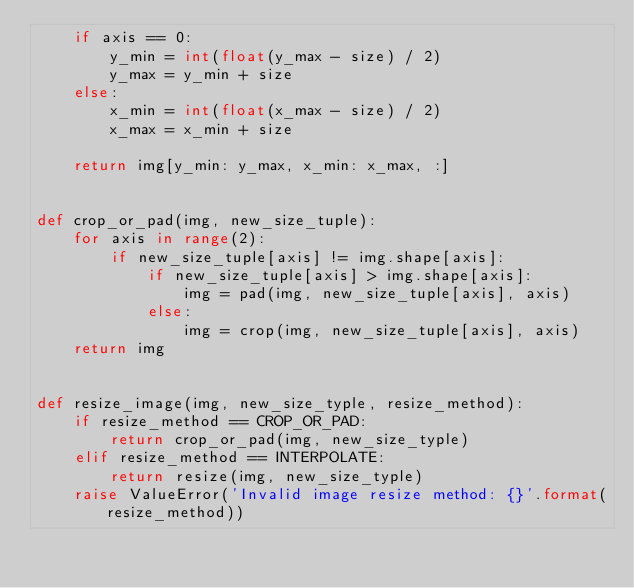<code> <loc_0><loc_0><loc_500><loc_500><_Python_>    if axis == 0:
        y_min = int(float(y_max - size) / 2)
        y_max = y_min + size
    else:
        x_min = int(float(x_max - size) / 2)
        x_max = x_min + size

    return img[y_min: y_max, x_min: x_max, :]


def crop_or_pad(img, new_size_tuple):
    for axis in range(2):
        if new_size_tuple[axis] != img.shape[axis]:
            if new_size_tuple[axis] > img.shape[axis]:
                img = pad(img, new_size_tuple[axis], axis)
            else:
                img = crop(img, new_size_tuple[axis], axis)
    return img


def resize_image(img, new_size_typle, resize_method):
    if resize_method == CROP_OR_PAD:
        return crop_or_pad(img, new_size_typle)
    elif resize_method == INTERPOLATE:
        return resize(img, new_size_typle)
    raise ValueError('Invalid image resize method: {}'.format(resize_method))
</code> 